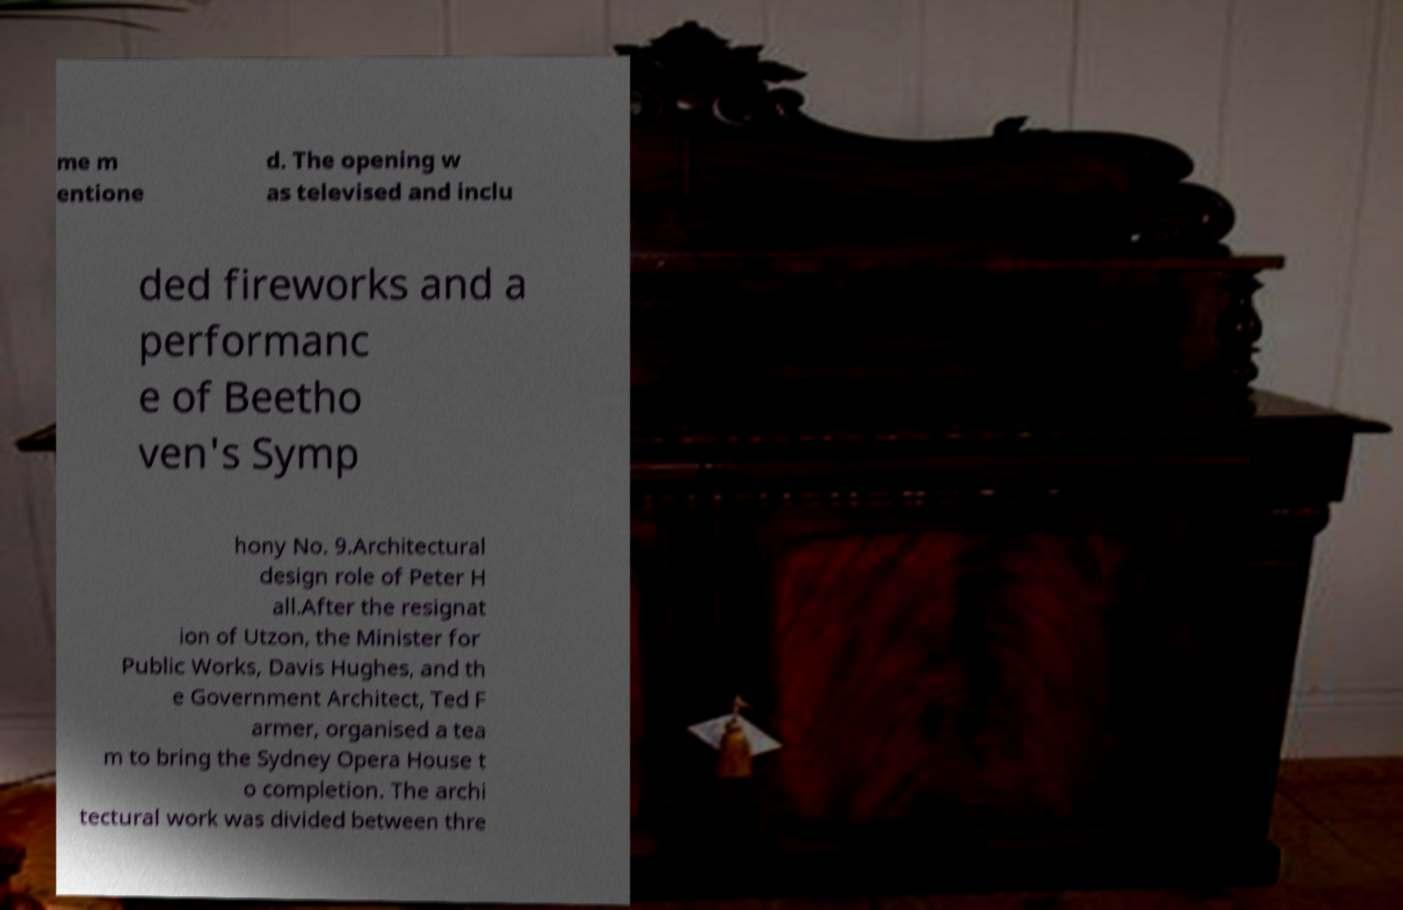I need the written content from this picture converted into text. Can you do that? me m entione d. The opening w as televised and inclu ded fireworks and a performanc e of Beetho ven's Symp hony No. 9.Architectural design role of Peter H all.After the resignat ion of Utzon, the Minister for Public Works, Davis Hughes, and th e Government Architect, Ted F armer, organised a tea m to bring the Sydney Opera House t o completion. The archi tectural work was divided between thre 